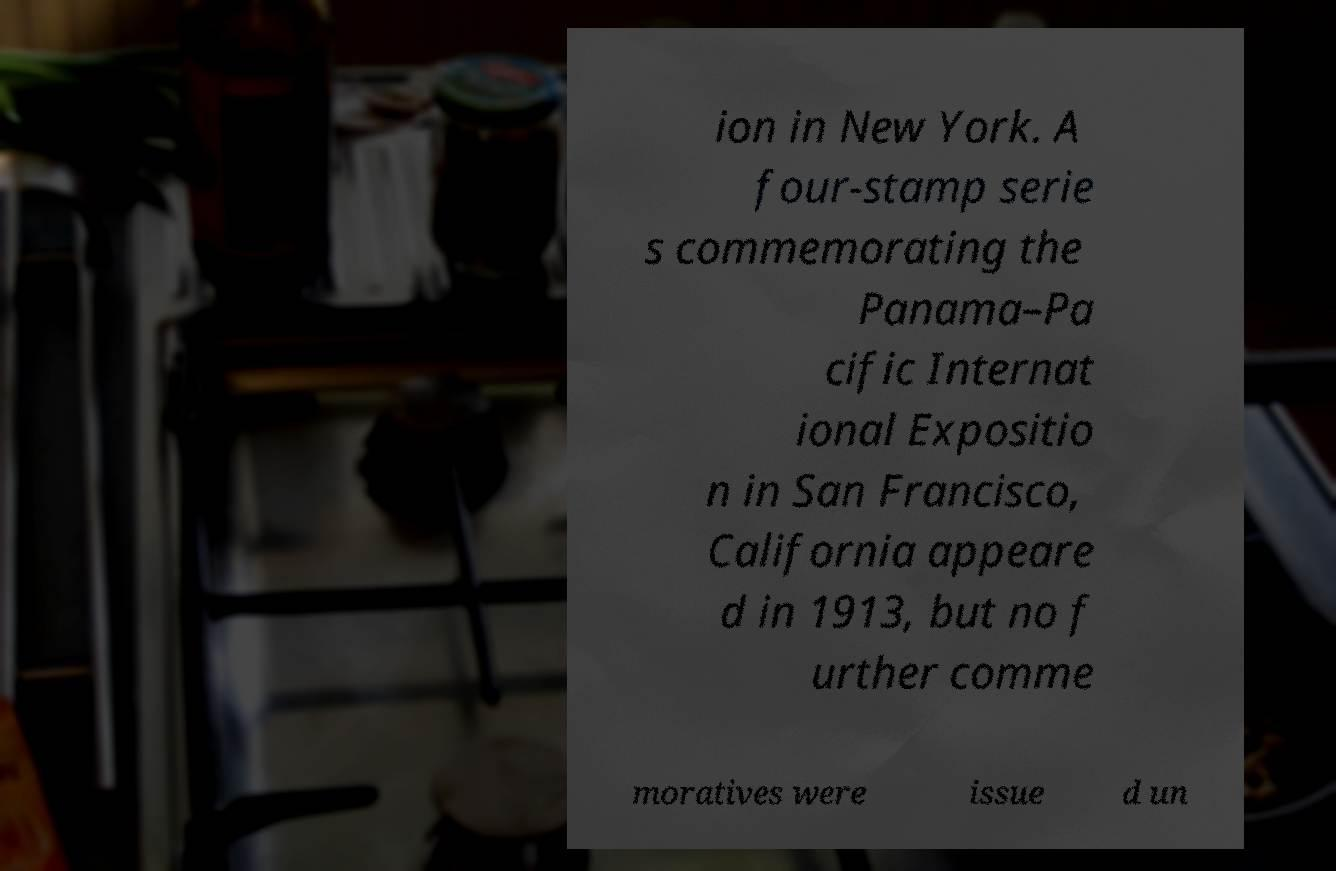Please identify and transcribe the text found in this image. ion in New York. A four-stamp serie s commemorating the Panama–Pa cific Internat ional Expositio n in San Francisco, California appeare d in 1913, but no f urther comme moratives were issue d un 